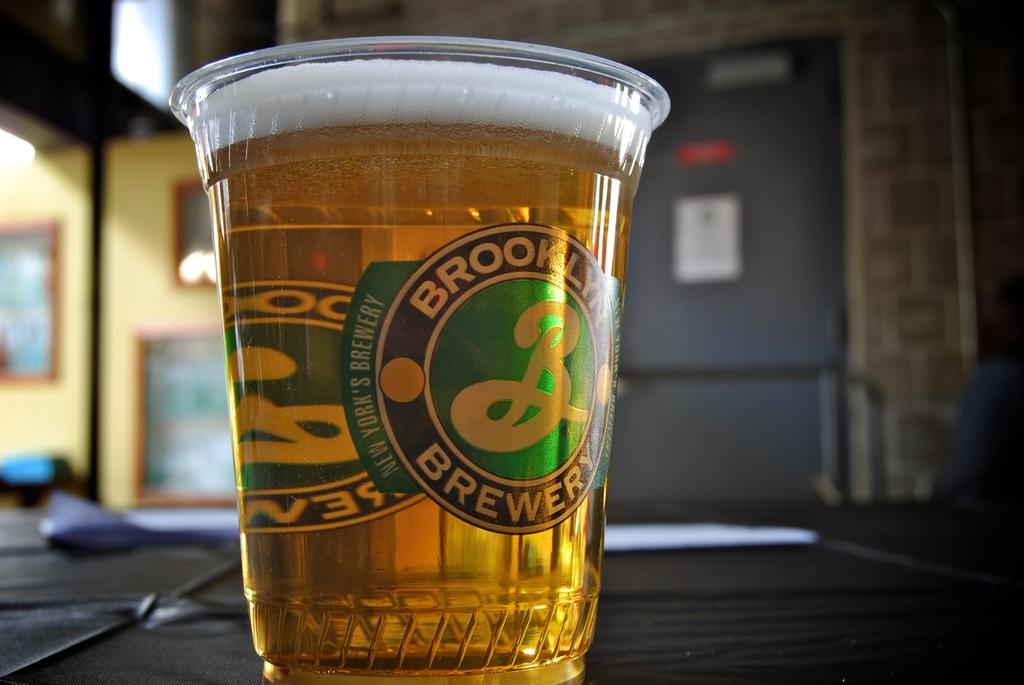Is it beer?
Your response must be concise. Yes. What is the name of this brewery?
Offer a very short reply. Brooklyn brewery. 